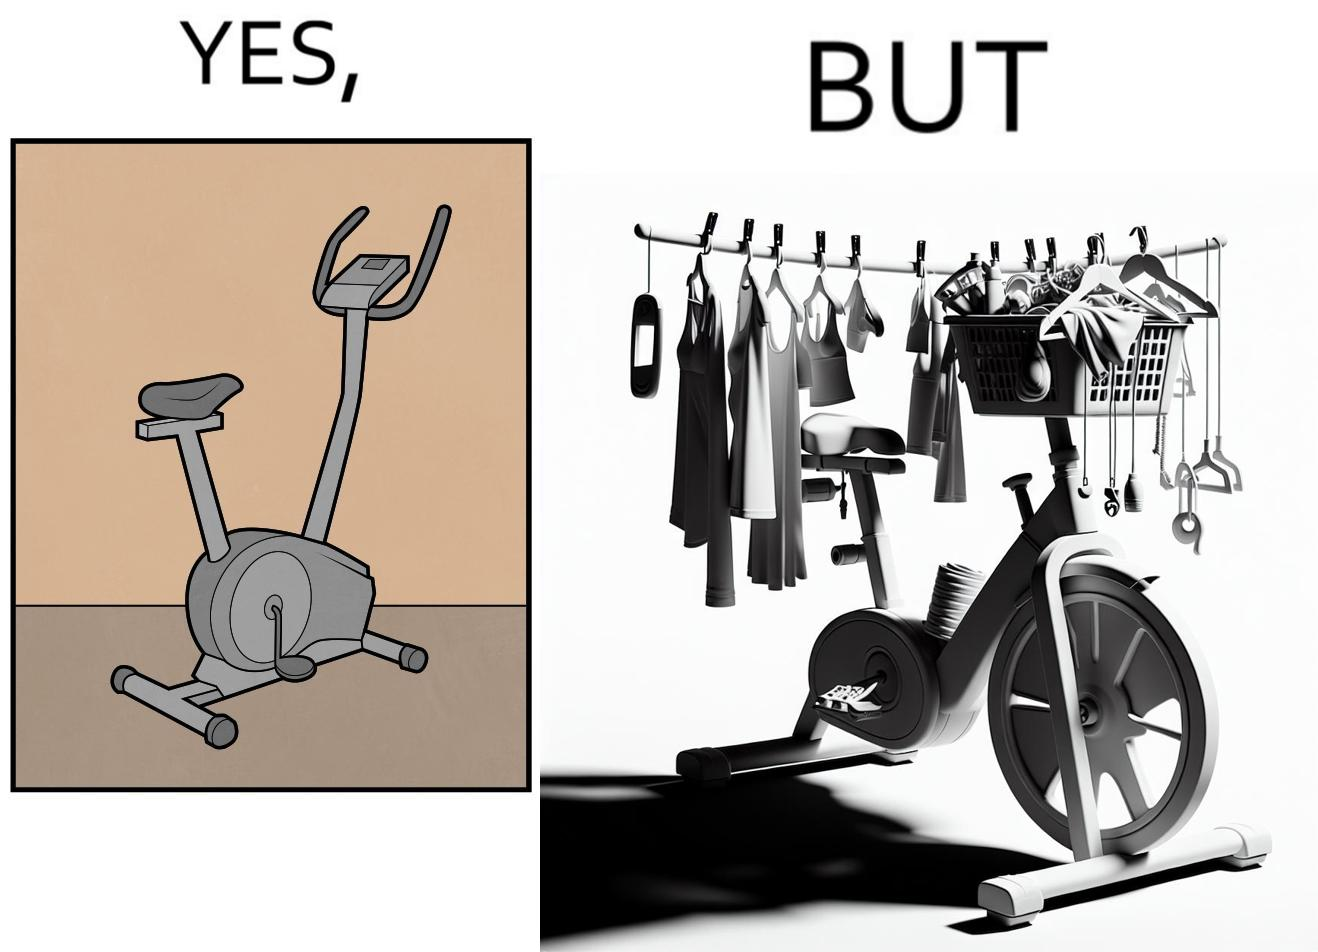What is shown in this image? The images are funny since they show an exercise bike has been bought but is not being used for its purpose, that is, exercising. It is rather being used to hang clothes, bags and other items 